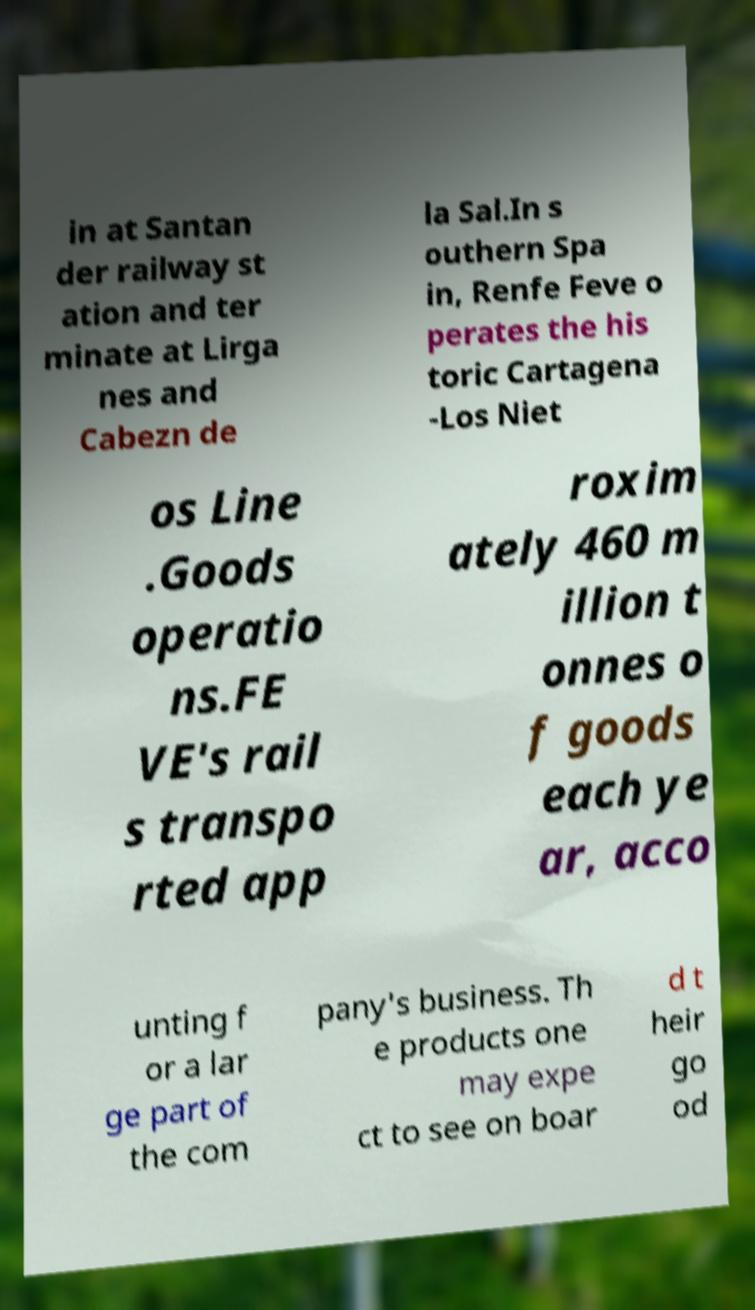I need the written content from this picture converted into text. Can you do that? in at Santan der railway st ation and ter minate at Lirga nes and Cabezn de la Sal.In s outhern Spa in, Renfe Feve o perates the his toric Cartagena -Los Niet os Line .Goods operatio ns.FE VE's rail s transpo rted app roxim ately 460 m illion t onnes o f goods each ye ar, acco unting f or a lar ge part of the com pany's business. Th e products one may expe ct to see on boar d t heir go od 